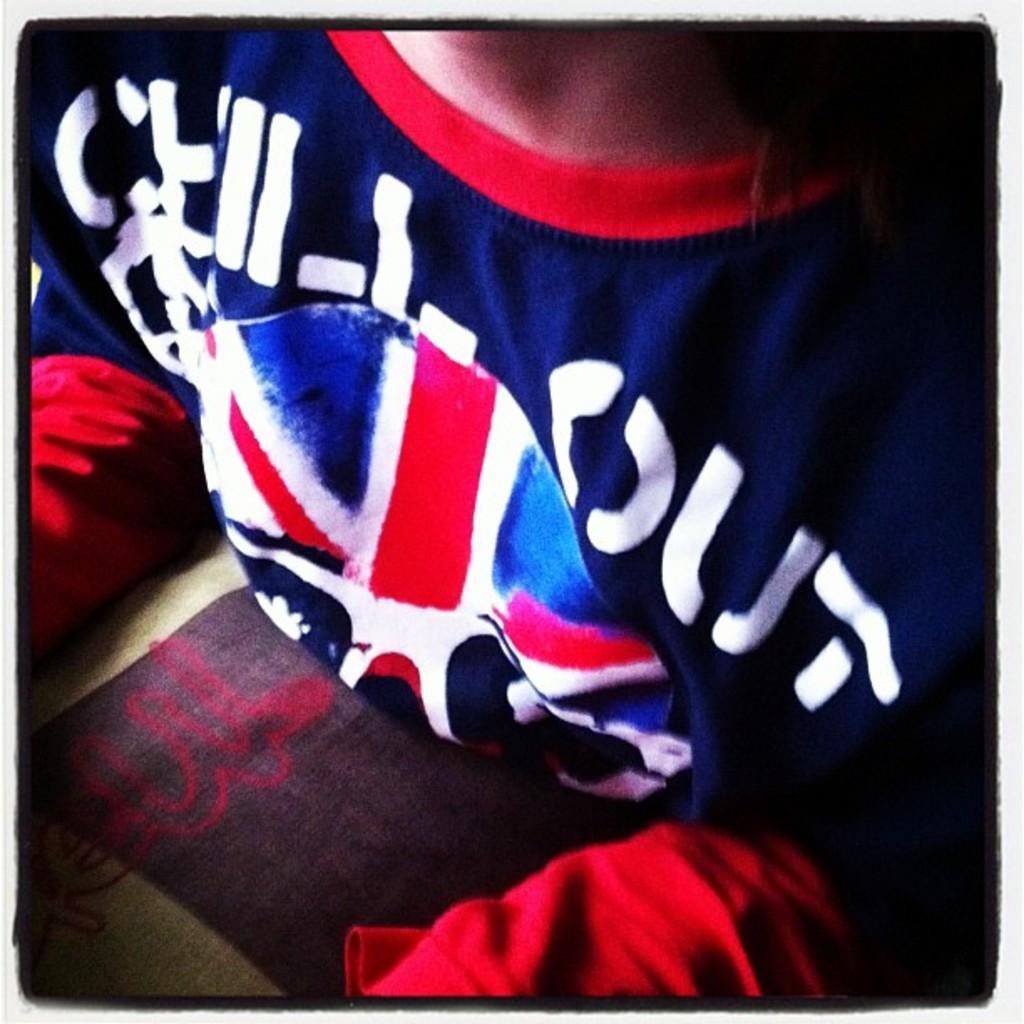What is shirt asking you to do?
Your answer should be compact. Chill out. The shirt wants you to chill what?
Your answer should be compact. Out. 